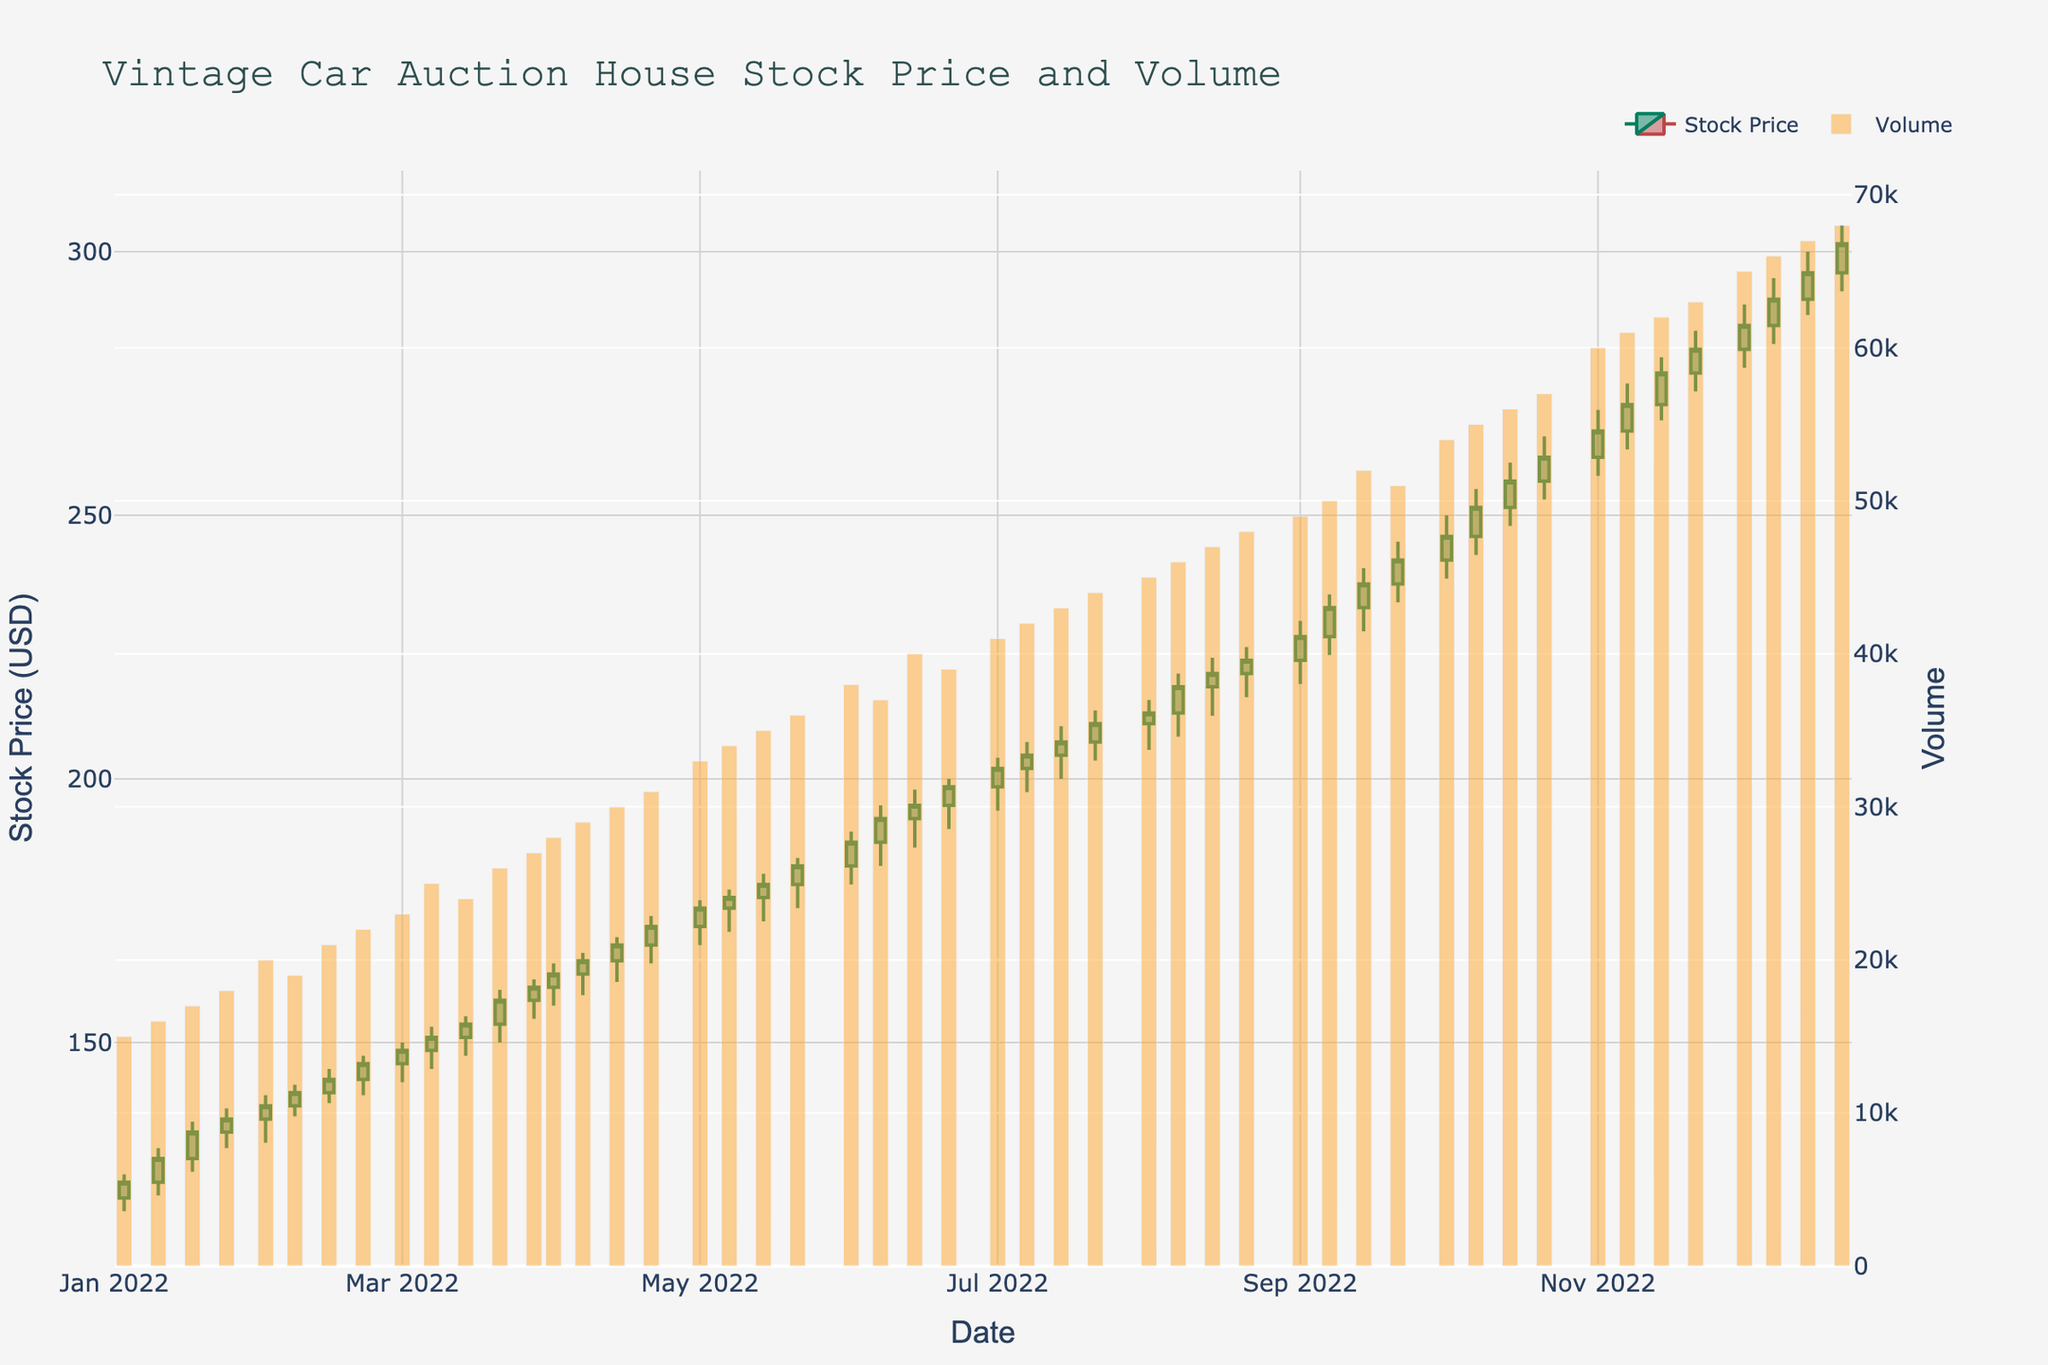What is the title of the plot? The title is located at the top of the figure in a larger font. It provides an overview of what the plot represents, which in this case includes both stock price and volume information for a vintage car auction house.
Answer: Vintage Car Auction House Stock Price and Volume How does the stock price trend from January to December 2022? By observing the candlestick patterns from January to December 2022, one can see that the stock price generally follows an upward trend, starting around 123.5 USD in January and reaching approximately 301.5 USD by the end of December.
Answer: It trends upward When did the stock price first cross 200 USD? By looking at the closing prices on the candlesticks, the stock price first crosses 200 USD in July 2022, specifically around July 1.
Answer: July 2022 What is the highest stock price observed, and when did it occur? The highest stock price is represented by the top of the highest candlestick wick, which occurred around December, reaching close to 305 USD.
Answer: 305 USD in December 2022 How does the trading volume change over the months? The volume bars at the bottom indicate that trading volume increases steadily over the months, starting at 15,000 in January and reaching 68,000 in December.
Answer: It increases steadily What is the average closing price from March to May 2022? To find the average, add the closing prices from March (158, 160.5, 163, 165.5, 168.5) and May (175.5, 177.5, 180, 183.5) and divide by the number of data points (9).
Answer: 169.5 USD Which month had the highest trading volume? The highest trading volume is represented by the tallest bar, which occurs in December, specifically the week ending on December 21, 2022, with a volume around 68,000.
Answer: December 2022 Compare the stock price increase between February and March versus August and September. Which period shows a greater increase? Compare the closing price at the start and end of February (138 to 158) and March (160.5 to 168.5) with the closing price from August (212.5 to 222.5) to September (227 to 241.5). Feb-March: 168.5-138 = 30.5; Aug-Sep: 241.5-217.5 = 24
Answer: February and March What patterns or seasonal fluctuations can you infer from the plot regarding the stock price of the vintage car auction house? Observing the plot, there’s a noticeable increase in both stock price and volume as the year progresses, suggesting higher interest and activity in vintage car auctions towards the end of the year, likely due to holiday seasons and year-end events.
Answer: Higher interest towards year-end In which month did the stock price see the largest single-week gain, and what was the gain? Look for the largest difference in closing prices between two consecutive candlesticks. The largest single-week gain appears to be in December, around December 14, with a jump from 291 USD to 296 USD, a 5 USD gain.
Answer: December 14, gain of 5 USD 